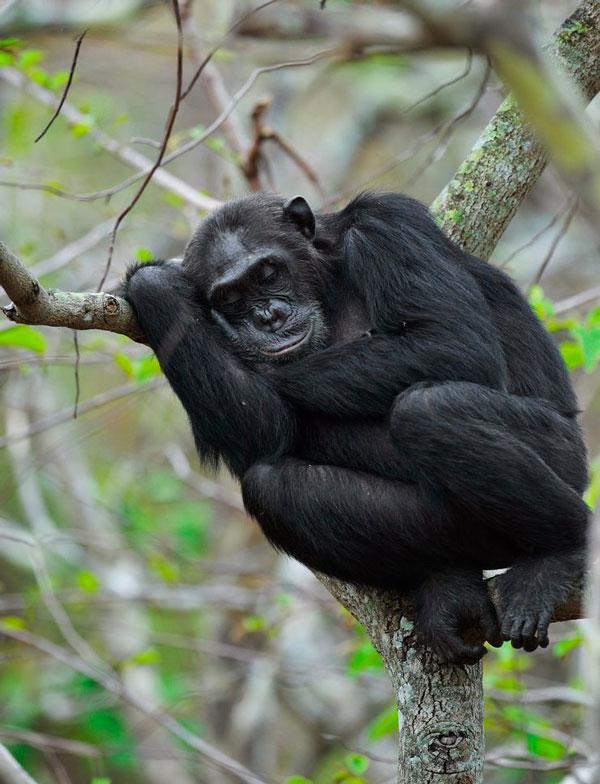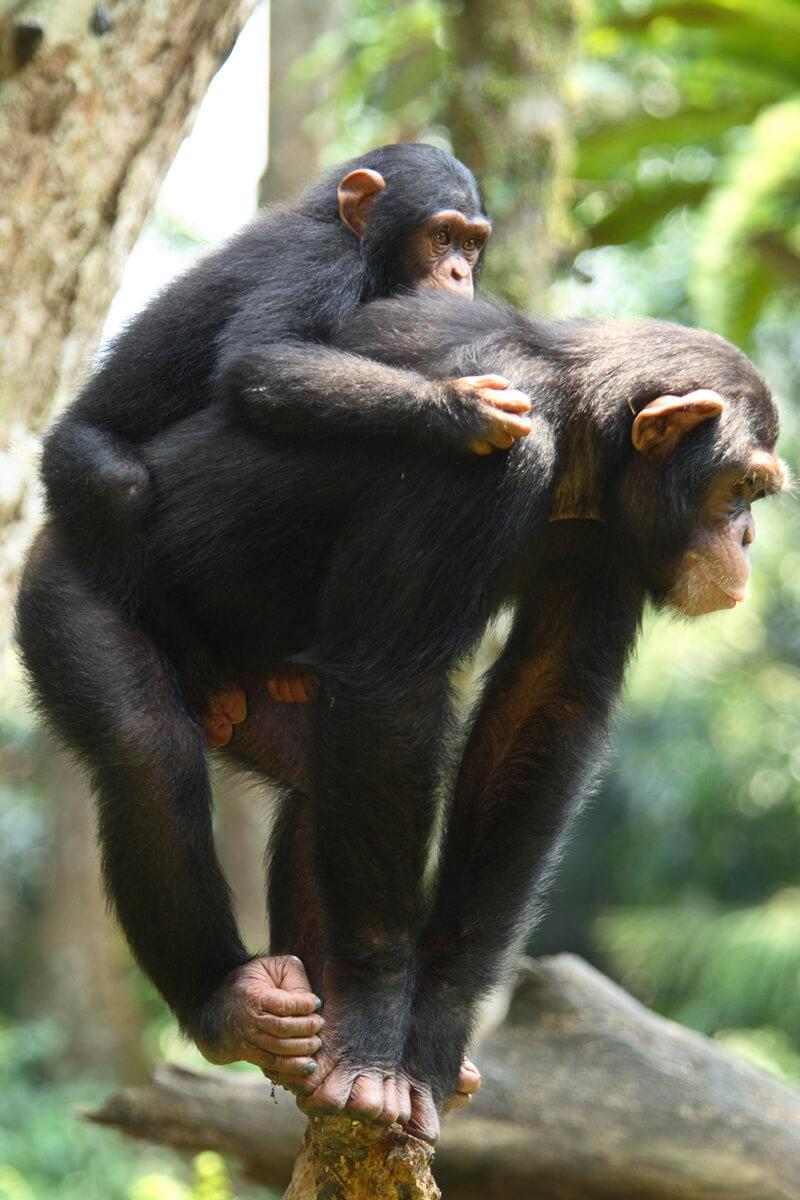The first image is the image on the left, the second image is the image on the right. Examine the images to the left and right. Is the description "The image on the right contains a baby and its mother." accurate? Answer yes or no. Yes. The first image is the image on the left, the second image is the image on the right. Evaluate the accuracy of this statement regarding the images: "The right image shows a chimp with an animal on its back.". Is it true? Answer yes or no. Yes. 